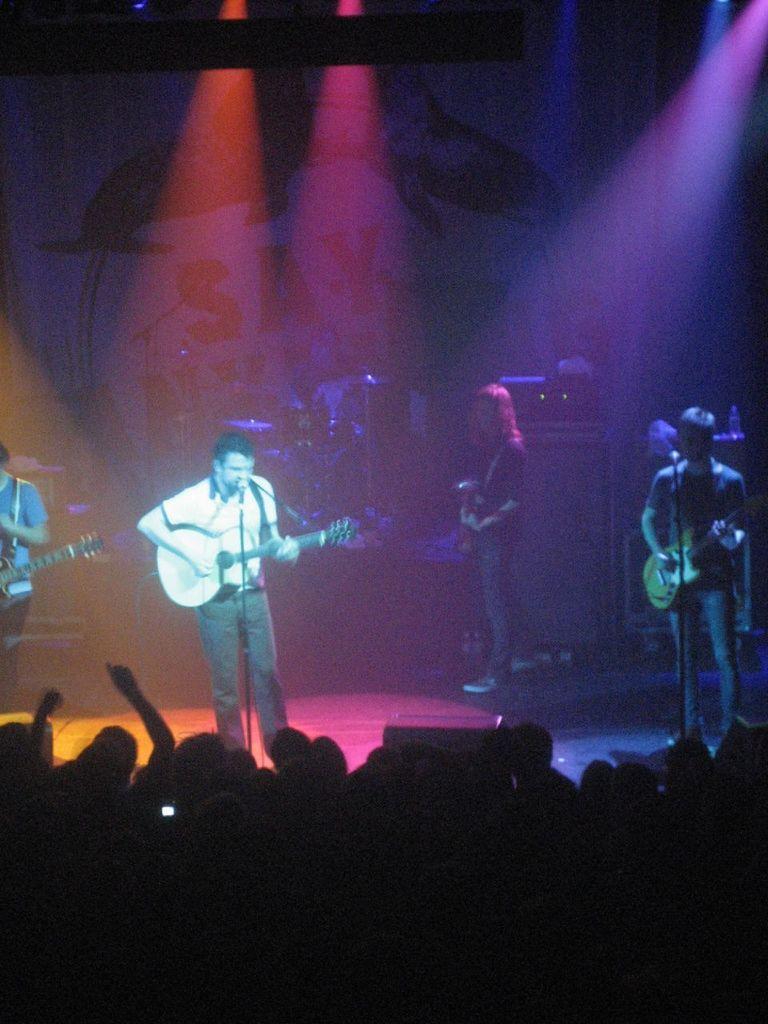Can you describe this image briefly? In this image in the middle there is a man he is playing guitar he wears t shirt and trouser. On the right there is a man he is playing guitar. At the bottom there are many people. In the background there are some people and lights and some musical instruments. 